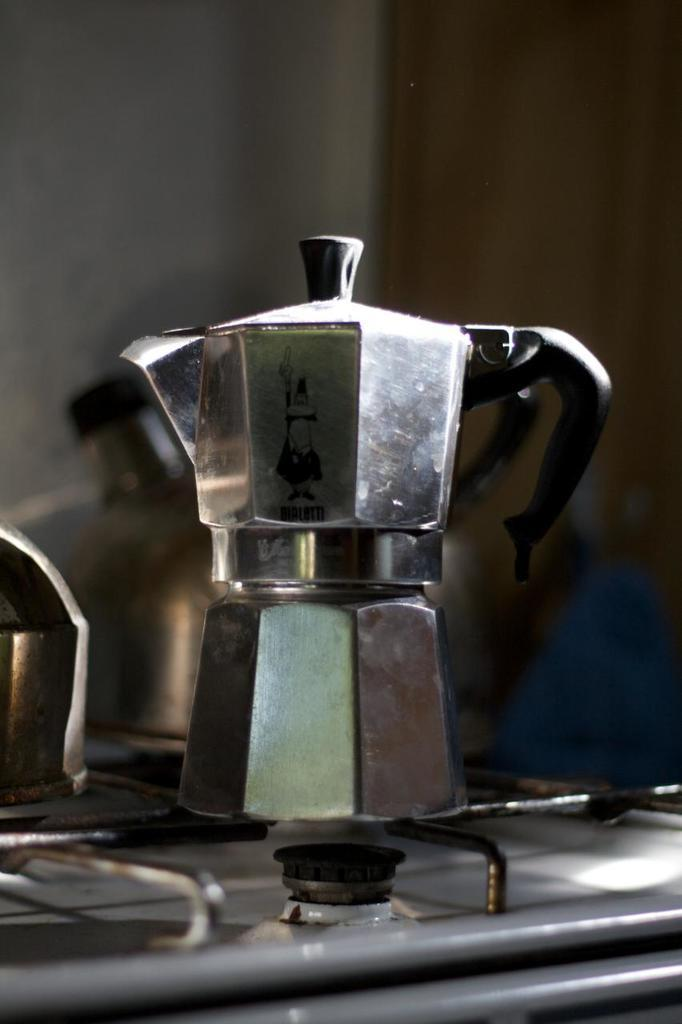What object is located in the middle of the image? There is a jar in the middle of the image. Where is the jar positioned in the image? The jar is on the stove. Can you describe the location of the jar in relation to other objects or elements in the image? The jar is the main focus of the image, and there are no other objects or elements mentioned in the provided facts. How many cows are visible in the image? There are no cows present in the image. What type of coach is standing next to the jar in the image? There is no coach present in the image. 